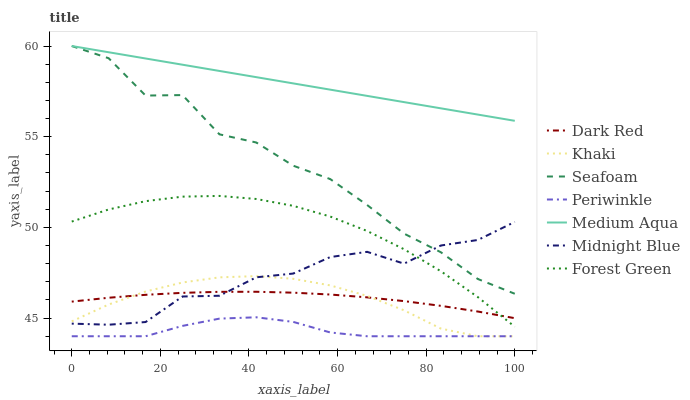Does Periwinkle have the minimum area under the curve?
Answer yes or no. Yes. Does Medium Aqua have the maximum area under the curve?
Answer yes or no. Yes. Does Midnight Blue have the minimum area under the curve?
Answer yes or no. No. Does Midnight Blue have the maximum area under the curve?
Answer yes or no. No. Is Medium Aqua the smoothest?
Answer yes or no. Yes. Is Seafoam the roughest?
Answer yes or no. Yes. Is Midnight Blue the smoothest?
Answer yes or no. No. Is Midnight Blue the roughest?
Answer yes or no. No. Does Khaki have the lowest value?
Answer yes or no. Yes. Does Midnight Blue have the lowest value?
Answer yes or no. No. Does Medium Aqua have the highest value?
Answer yes or no. Yes. Does Midnight Blue have the highest value?
Answer yes or no. No. Is Periwinkle less than Seafoam?
Answer yes or no. Yes. Is Midnight Blue greater than Periwinkle?
Answer yes or no. Yes. Does Forest Green intersect Dark Red?
Answer yes or no. Yes. Is Forest Green less than Dark Red?
Answer yes or no. No. Is Forest Green greater than Dark Red?
Answer yes or no. No. Does Periwinkle intersect Seafoam?
Answer yes or no. No. 